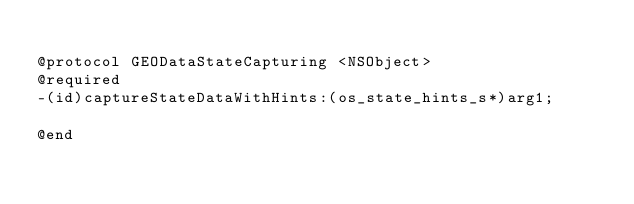<code> <loc_0><loc_0><loc_500><loc_500><_C_>
@protocol GEODataStateCapturing <NSObject>
@required
-(id)captureStateDataWithHints:(os_state_hints_s*)arg1;

@end

</code> 